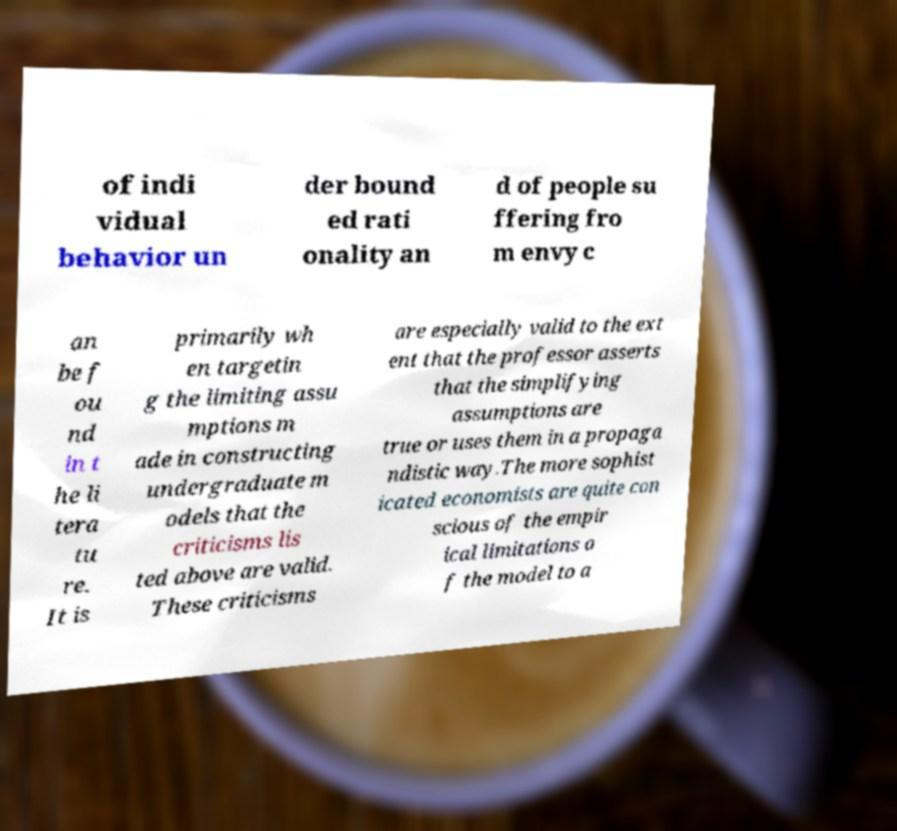What messages or text are displayed in this image? I need them in a readable, typed format. of indi vidual behavior un der bound ed rati onality an d of people su ffering fro m envy c an be f ou nd in t he li tera tu re. It is primarily wh en targetin g the limiting assu mptions m ade in constructing undergraduate m odels that the criticisms lis ted above are valid. These criticisms are especially valid to the ext ent that the professor asserts that the simplifying assumptions are true or uses them in a propaga ndistic way.The more sophist icated economists are quite con scious of the empir ical limitations o f the model to a 